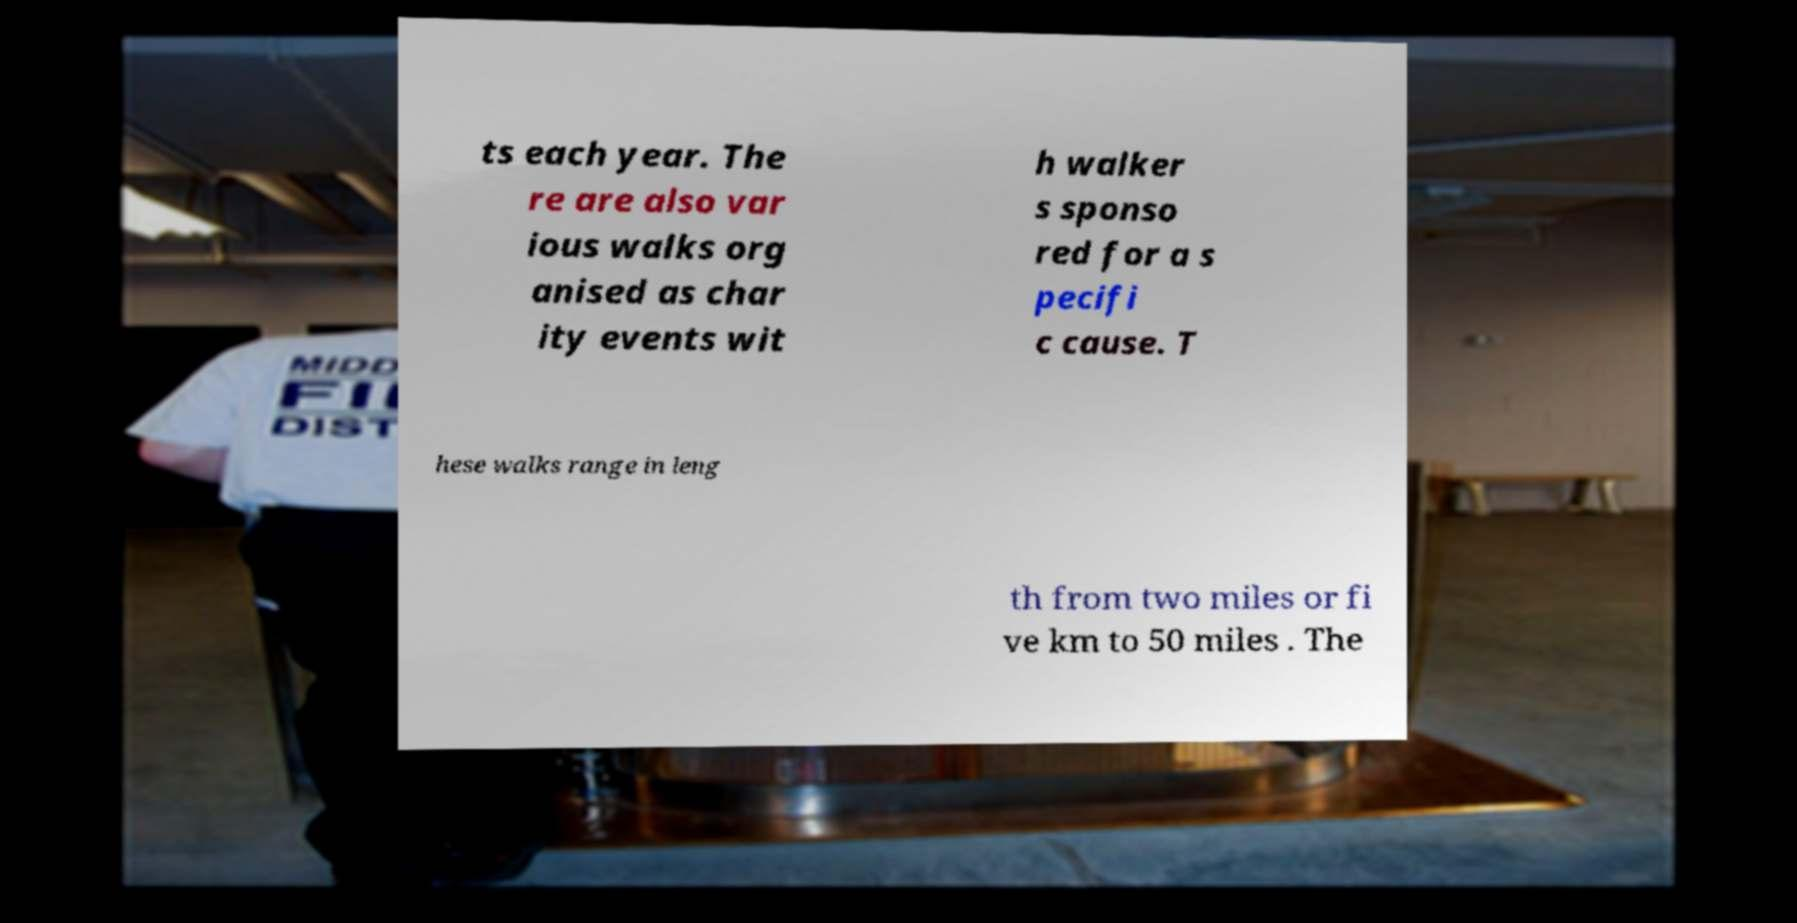Could you extract and type out the text from this image? ts each year. The re are also var ious walks org anised as char ity events wit h walker s sponso red for a s pecifi c cause. T hese walks range in leng th from two miles or fi ve km to 50 miles . The 